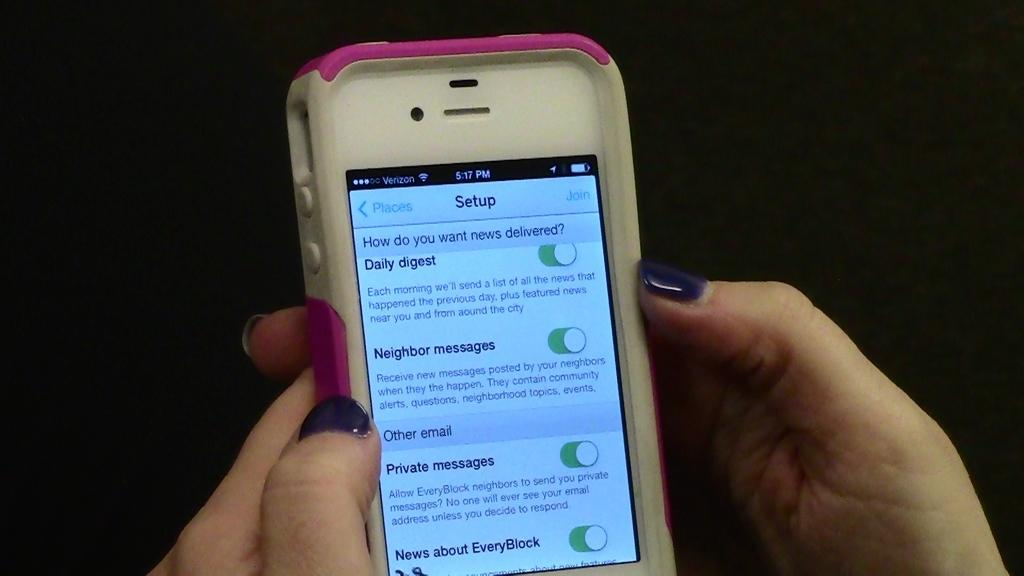<image>
Give a short and clear explanation of the subsequent image. A cell phone displaying a screen that says Setup on it. 